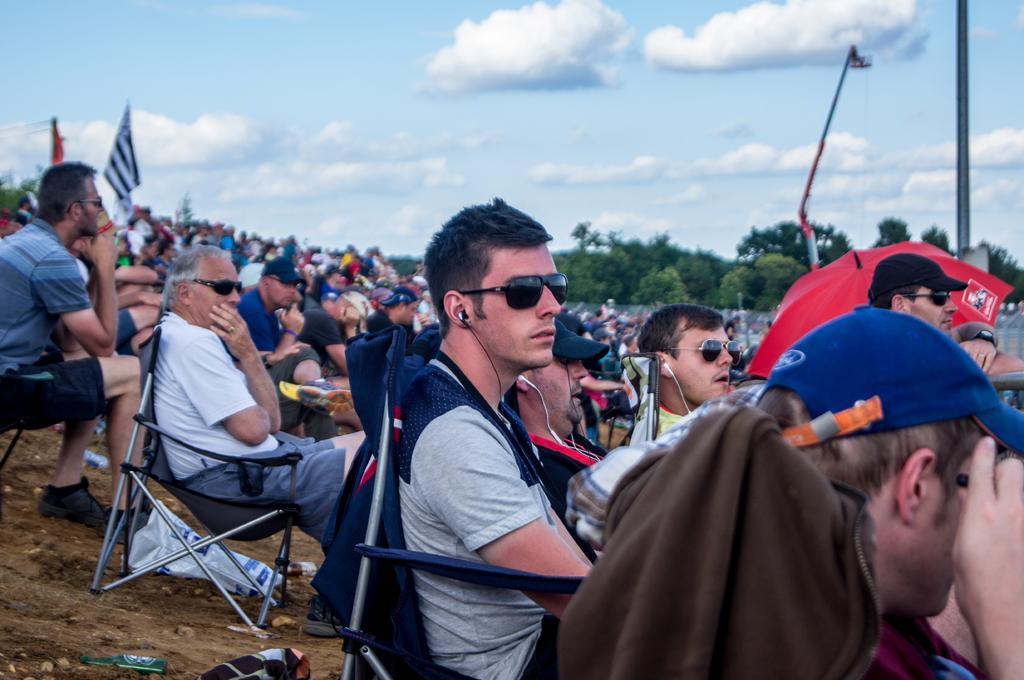In one or two sentences, can you explain what this image depicts? There are group of people sitting in the chairs. These are the trees. This looks like a pole. I can see the trees in the sky. I think this is a flag hanging. 